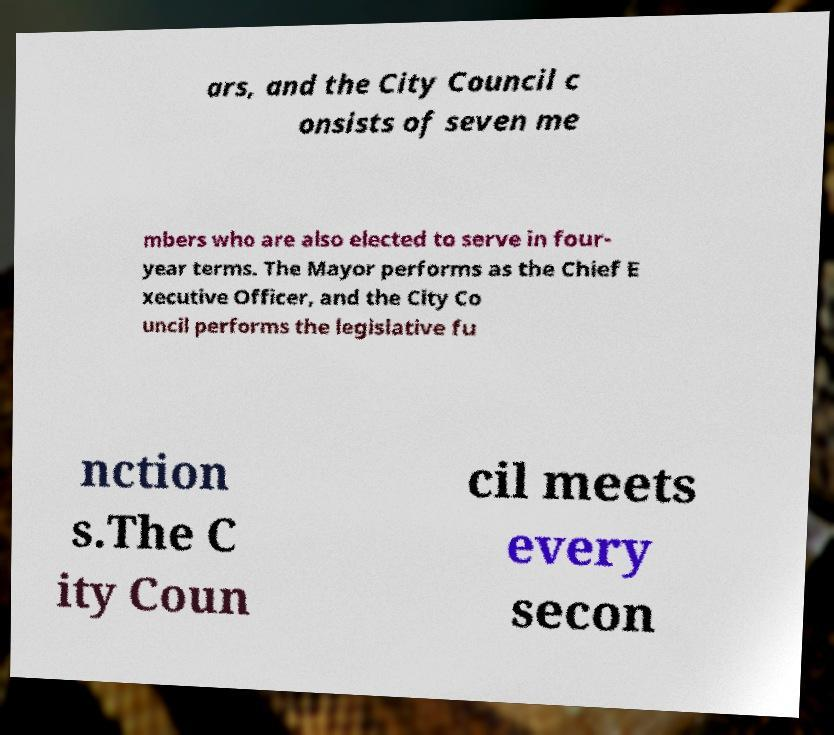For documentation purposes, I need the text within this image transcribed. Could you provide that? ars, and the City Council c onsists of seven me mbers who are also elected to serve in four- year terms. The Mayor performs as the Chief E xecutive Officer, and the City Co uncil performs the legislative fu nction s.The C ity Coun cil meets every secon 